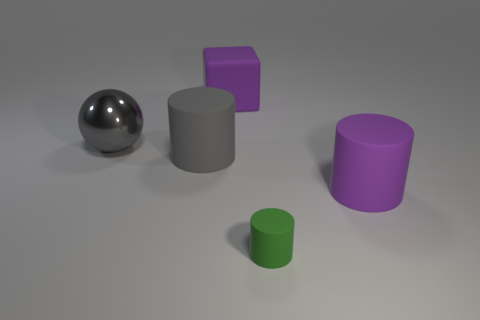What number of other tiny green matte things are the same shape as the tiny thing? After examining the image closely, there is one tiny green matte cylinder. There are no other objects of the same shape and color. Therefore, the count of other tiny green matte cylinders is zero. 